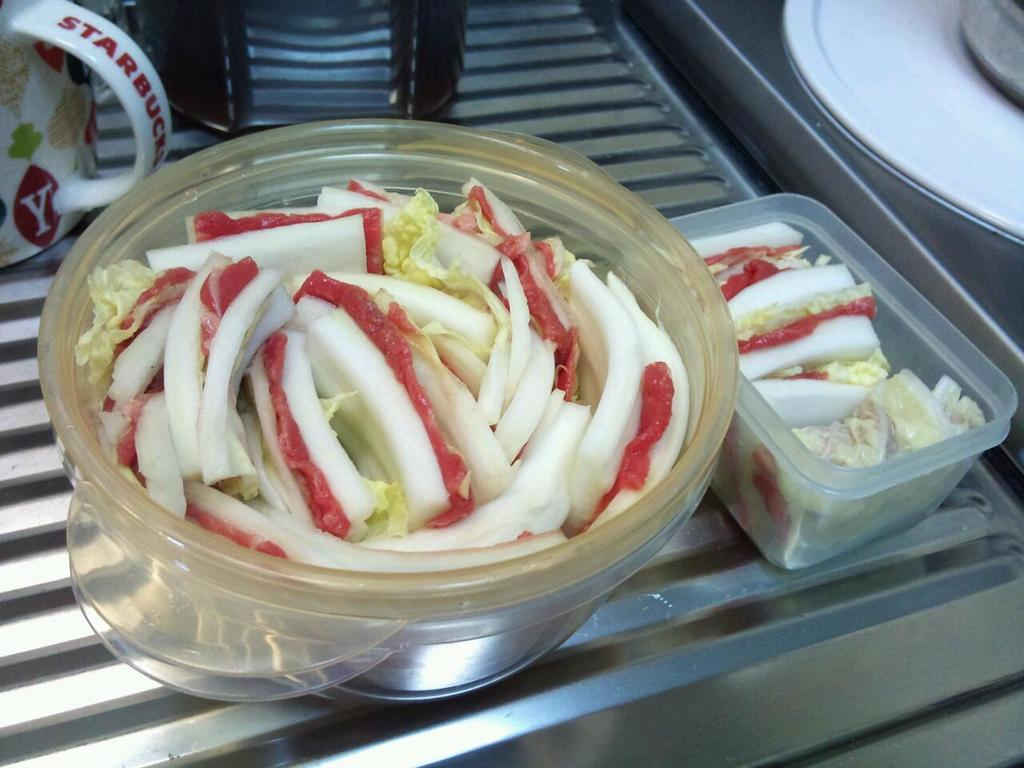What is in the bowl that is visible in the image? There is food in a bowl in the image. What can be seen on the left side of the image? There is a cup on the left side of the image. What is depicted on the right side of the image? There are planets depicted on the right side of the image. Can you tell me how many friends are holding hands with the planets in the image? There are no friends or hands depicted in the image; it only features a bowl of food, a cup, and planets. 